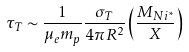<formula> <loc_0><loc_0><loc_500><loc_500>\tau _ { T } \sim \frac { 1 } { \mu _ { e } m _ { p } } \frac { \sigma _ { T } } { 4 \pi R ^ { 2 } } \left ( \frac { M _ { N i ^ { * } } } { X } \right )</formula> 